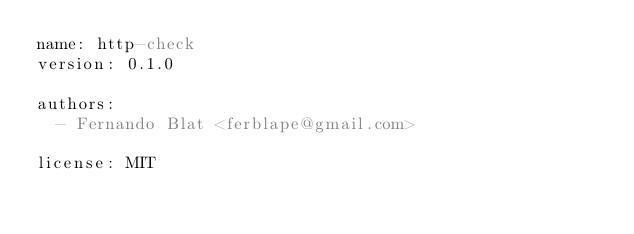Convert code to text. <code><loc_0><loc_0><loc_500><loc_500><_YAML_>name: http-check
version: 0.1.0

authors:
  - Fernando Blat <ferblape@gmail.com>

license: MIT
</code> 